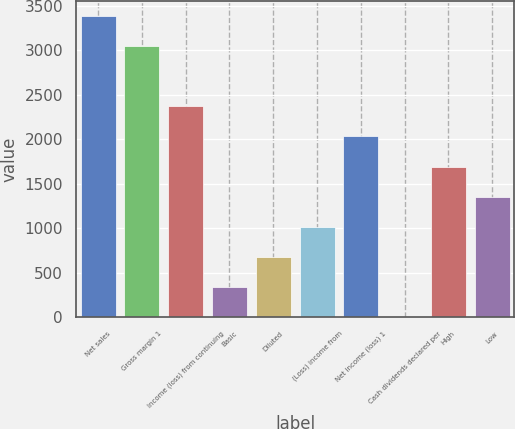Convert chart. <chart><loc_0><loc_0><loc_500><loc_500><bar_chart><fcel>Net sales<fcel>Gross margin 1<fcel>Income (loss) from continuing<fcel>Basic<fcel>Diluted<fcel>(Loss) income from<fcel>Net income (loss) 1<fcel>Cash dividends declared per<fcel>High<fcel>Low<nl><fcel>3387.03<fcel>3048.34<fcel>2370.96<fcel>338.82<fcel>677.51<fcel>1016.2<fcel>2032.27<fcel>0.13<fcel>1693.58<fcel>1354.89<nl></chart> 